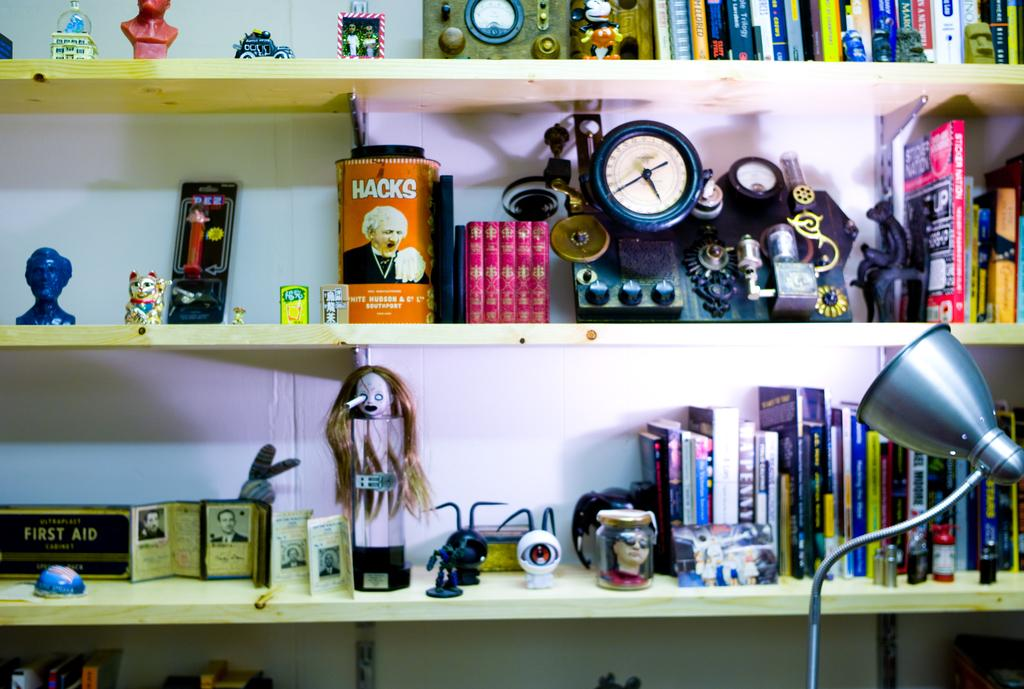What is located in the front of the image? There is a light lamp in the front of the image. On which side of the image is the light lamp? The light lamp is on the right side. What can be seen in the background of the image? There is the shelf contains objects such as dolls, books, blocks, and toys. What type of throat is visible in the image? There is no throat visible in the image. How many books are present on the shelf in the image? The provided facts do not specify the exact number of books on the shelf, only that there are books among other objects. 